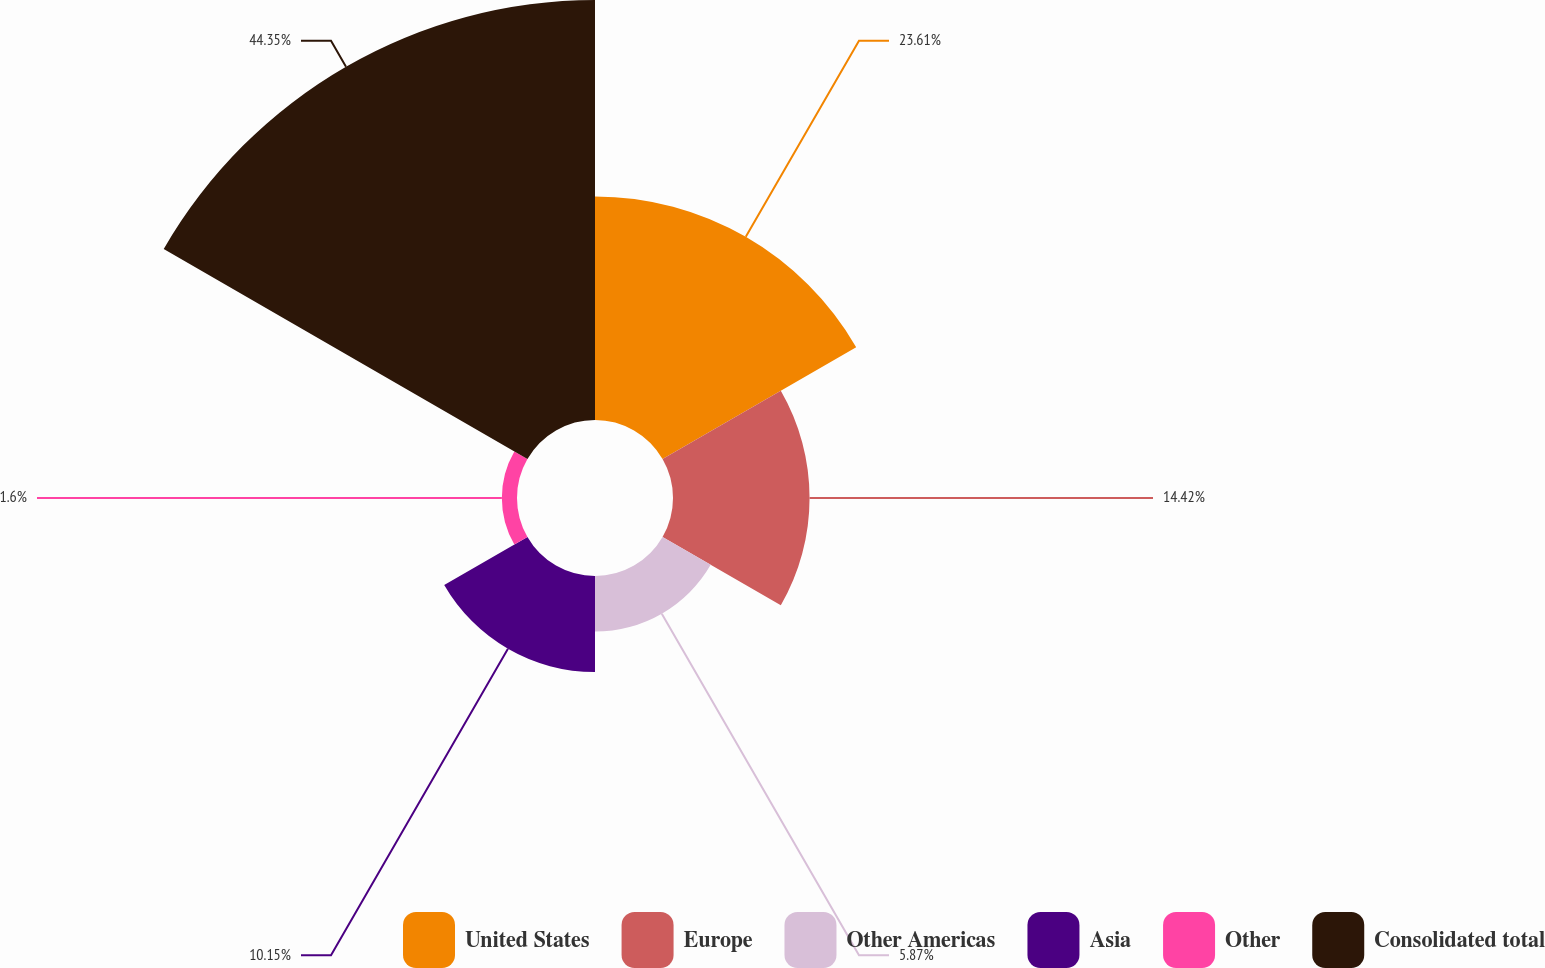<chart> <loc_0><loc_0><loc_500><loc_500><pie_chart><fcel>United States<fcel>Europe<fcel>Other Americas<fcel>Asia<fcel>Other<fcel>Consolidated total<nl><fcel>23.61%<fcel>14.42%<fcel>5.87%<fcel>10.15%<fcel>1.6%<fcel>44.35%<nl></chart> 